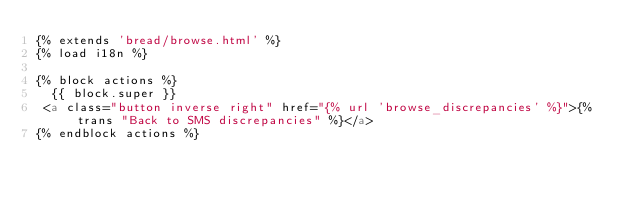Convert code to text. <code><loc_0><loc_0><loc_500><loc_500><_HTML_>{% extends 'bread/browse.html' %}
{% load i18n %}

{% block actions %}
  {{ block.super }}
 <a class="button inverse right" href="{% url 'browse_discrepancies' %}">{% trans "Back to SMS discrepancies" %}</a>
{% endblock actions %}
</code> 